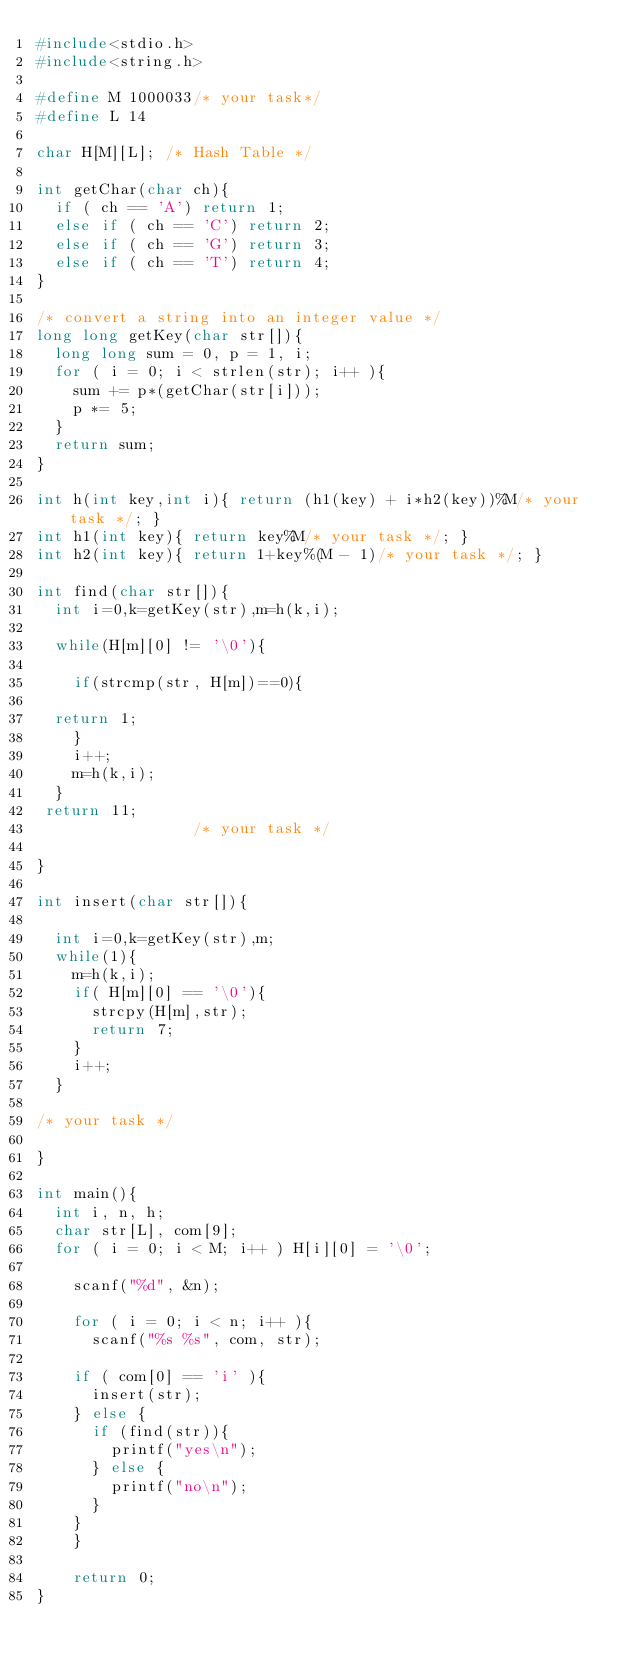<code> <loc_0><loc_0><loc_500><loc_500><_C_>#include<stdio.h>
#include<string.h>

#define M 1000033/* your task*/
#define L 14

char H[M][L]; /* Hash Table */

int getChar(char ch){
  if ( ch == 'A') return 1;
  else if ( ch == 'C') return 2;
  else if ( ch == 'G') return 3;
  else if ( ch == 'T') return 4;
}

/* convert a string into an integer value */
long long getKey(char str[]){
  long long sum = 0, p = 1, i;
  for ( i = 0; i < strlen(str); i++ ){
    sum += p*(getChar(str[i]));
    p *= 5;
  }
  return sum;
}

int h(int key,int i){ return (h1(key) + i*h2(key))%M/* your task */; }
int h1(int key){ return key%M/* your task */; }
int h2(int key){ return 1+key%(M - 1)/* your task */; }

int find(char str[]){
  int i=0,k=getKey(str),m=h(k,i);

  while(H[m][0] != '\0'){
   
    if(strcmp(str, H[m])==0){
  
  return 1;
    }
    i++;
    m=h(k,i);
  }
 return 11;
                 /* your task */

}

int insert(char str[]){

  int i=0,k=getKey(str),m;
  while(1){
    m=h(k,i);
    if( H[m][0] == '\0'){
      strcpy(H[m],str);
      return 7;
    }
    i++;
  }

/* your task */
  
}

int main(){
  int i, n, h;
  char str[L], com[9];
  for ( i = 0; i < M; i++ ) H[i][0] = '\0';
  
    scanf("%d", &n);
    
    for ( i = 0; i < n; i++ ){
      scanf("%s %s", com, str);
      
	if ( com[0] == 'i' ){
	  insert(str);
	} else {
	  if (find(str)){
	    printf("yes\n");
	  } else {
	    printf("no\n");
	  }
	}
    }
    
    return 0;
}</code> 